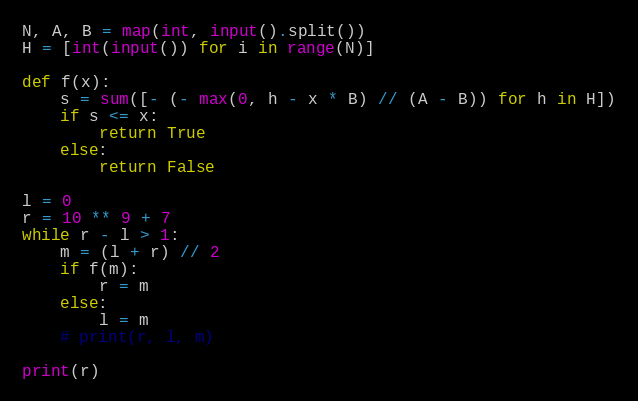<code> <loc_0><loc_0><loc_500><loc_500><_Python_>N, A, B = map(int, input().split())
H = [int(input()) for i in range(N)]
    
def f(x):
    s = sum([- (- max(0, h - x * B) // (A - B)) for h in H])
    if s <= x:
        return True
    else:
        return False
    
l = 0
r = 10 ** 9 + 7
while r - l > 1:
    m = (l + r) // 2
    if f(m):
        r = m
    else:
        l = m
    # print(r, l, m)
        
print(r)</code> 